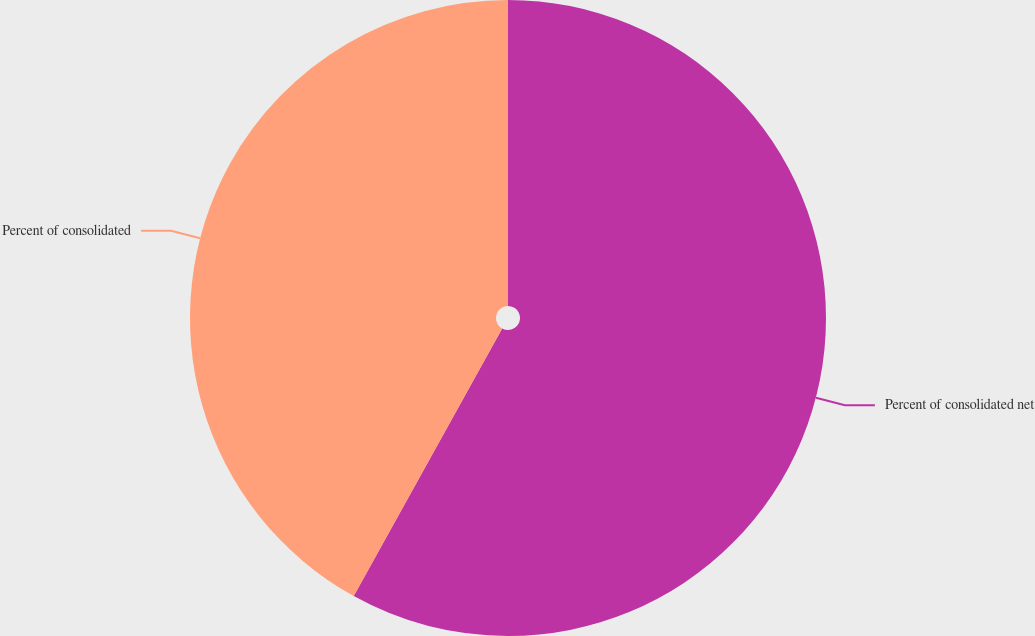Convert chart. <chart><loc_0><loc_0><loc_500><loc_500><pie_chart><fcel>Percent of consolidated net<fcel>Percent of consolidated<nl><fcel>58.06%<fcel>41.94%<nl></chart> 